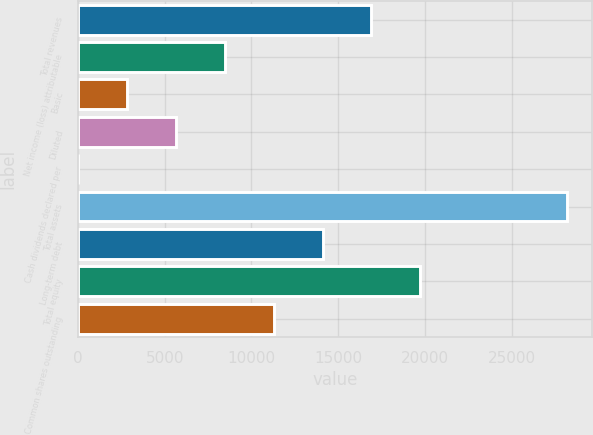Convert chart to OTSL. <chart><loc_0><loc_0><loc_500><loc_500><bar_chart><fcel>Total revenues<fcel>Net income (loss) attributable<fcel>Basic<fcel>Diluted<fcel>Cash dividends declared per<fcel>Total assets<fcel>Long-term debt<fcel>Total equity<fcel>Common shares outstanding<nl><fcel>16911.8<fcel>8456.22<fcel>2819.14<fcel>5637.68<fcel>0.6<fcel>28186<fcel>14093.3<fcel>19730.4<fcel>11274.8<nl></chart> 